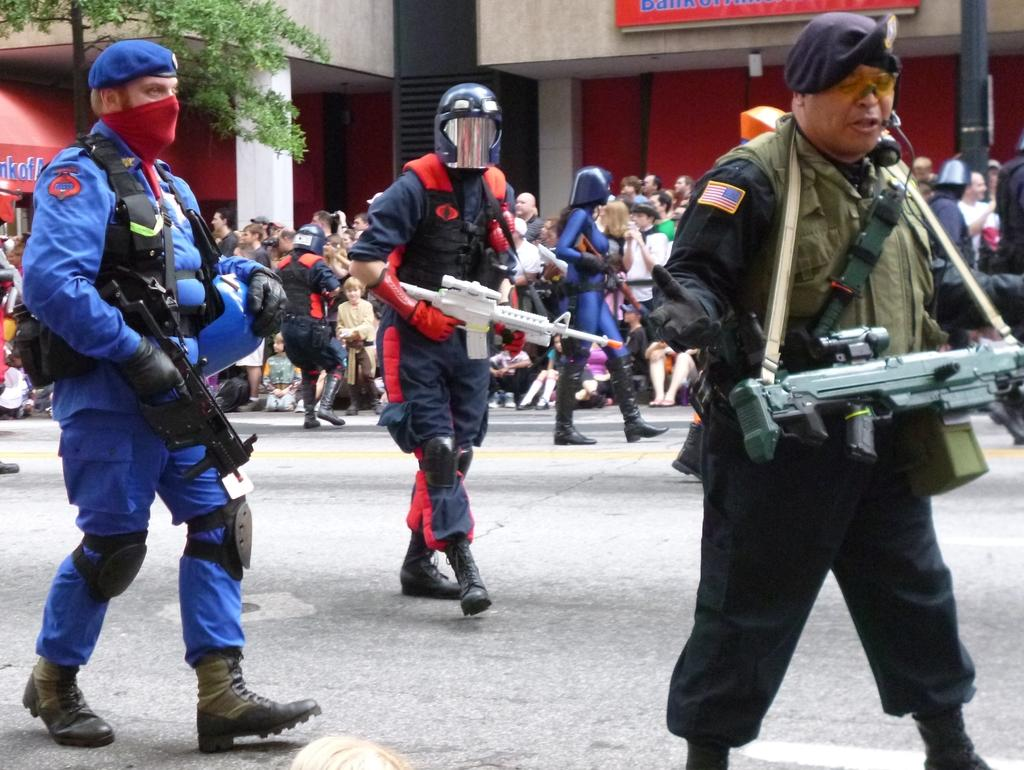Who or what is present in the image? There are people in the image. What are the people holding in the image? The people are holding rifles. What protective gear are the people wearing in the image? The people are wearing helmets. What can be seen at the bottom of the image? There is a road at the bottom of the image. What structures can be seen in the background of the image? There are buildings in the background of the image. What type of vegetation is on the left side of the image? There is a tree on the left side of the image. What type of bells can be heard ringing in the image? There are no bells present in the image, and therefore no sounds can be heard. Is there a pig visible in the image? There is no pig present in the image. 